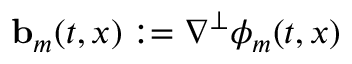Convert formula to latex. <formula><loc_0><loc_0><loc_500><loc_500>{ b } _ { m } ( t , x ) \colon = \nabla ^ { \perp } \phi _ { m } ( t , x )</formula> 